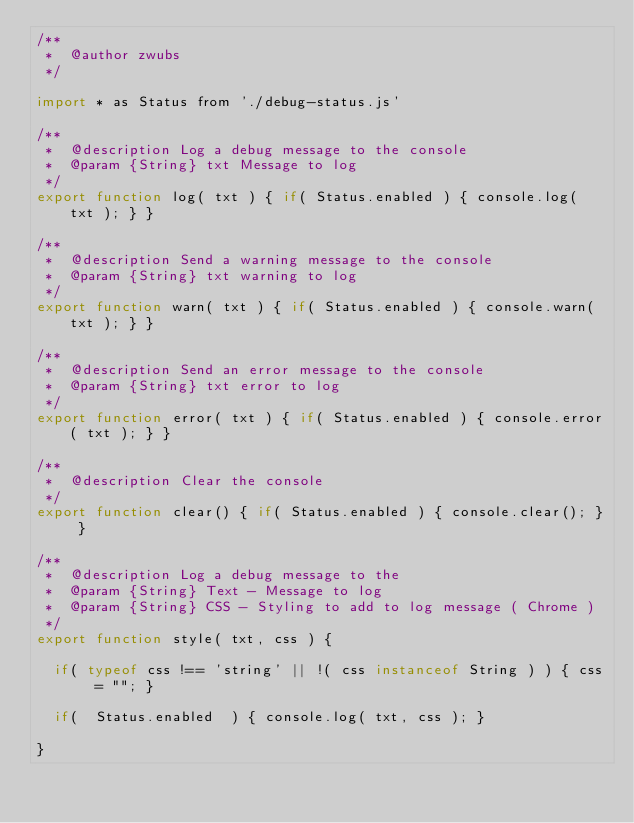Convert code to text. <code><loc_0><loc_0><loc_500><loc_500><_JavaScript_>/**
 *	@author zwubs
 */

import * as Status from './debug-status.js'

/**
 * 	@description Log a debug message to the console
 *	@param {String} txt Message to log
 */
export function log( txt ) { if( Status.enabled ) { console.log( txt ); } }

/**
 * 	@description Send a warning message to the console
 *	@param {String} txt warning to log
 */
export function warn( txt ) { if( Status.enabled ) { console.warn( txt ); } }

/**
 * 	@description Send an error message to the console
 *	@param {String} txt error to log
 */
export function error( txt ) { if( Status.enabled ) { console.error( txt ); } }

/**
 * 	@description Clear the console
 */
export function clear() { if( Status.enabled ) { console.clear(); } }

/**
 * 	@description Log a debug message to the
 *	@param {String} Text - Message to log
 *	@param {String} CSS - Styling to add to log message ( Chrome )
 */
export function style( txt, css ) {

	if( typeof css !== 'string' || !( css instanceof String ) ) { css = ""; }

	if(  Status.enabled  ) { console.log( txt, css ); }

}
</code> 